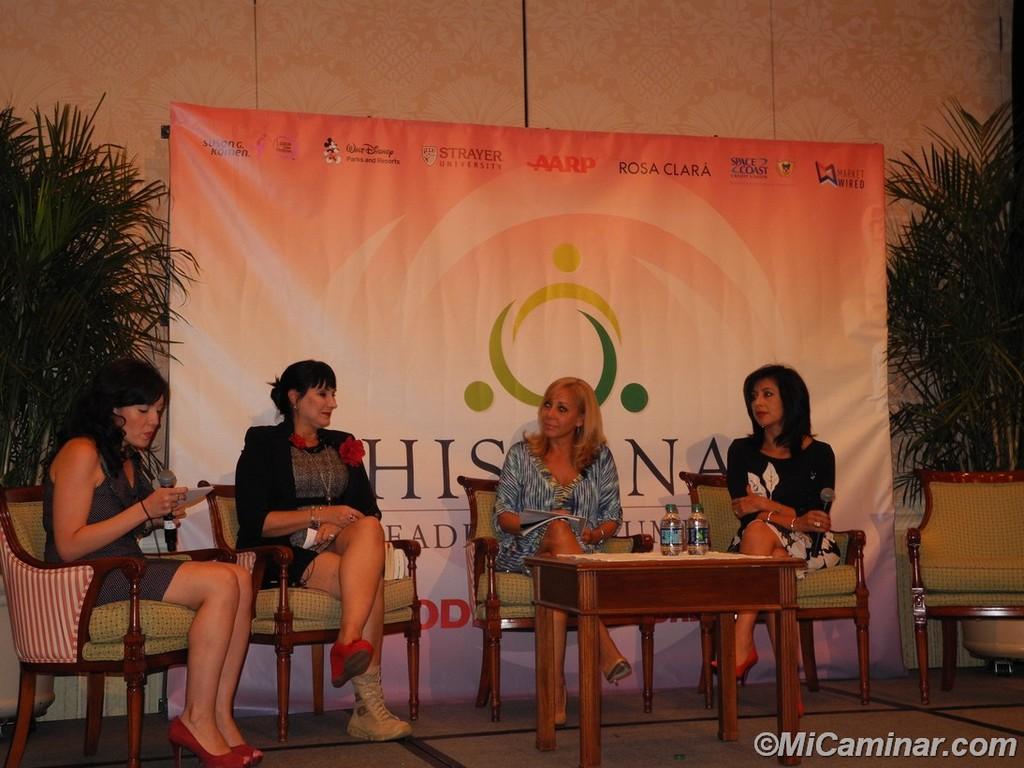Can you describe this image briefly? In image I can see a group of women are sitting on a chair in front of a table. Behind these women I can see in there is a banner and few plants on the floor. 